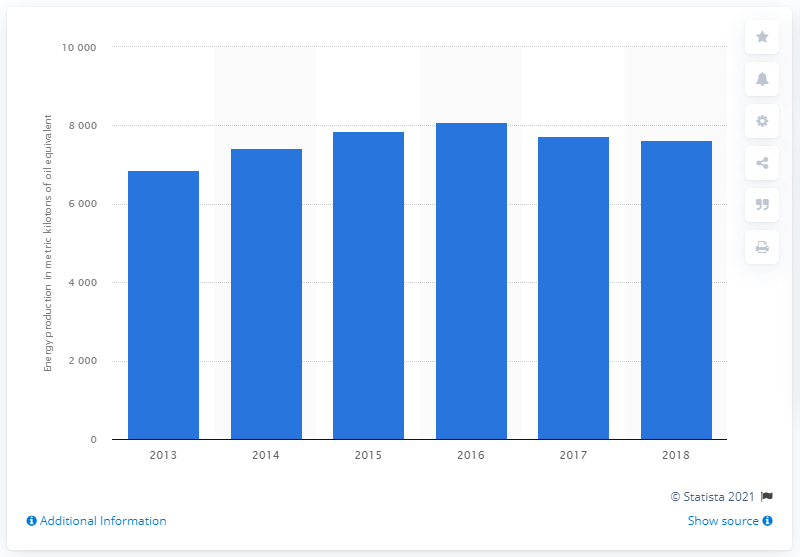Draw attention to some important aspects in this diagram. In 2017, biogas energy production began to decline. 